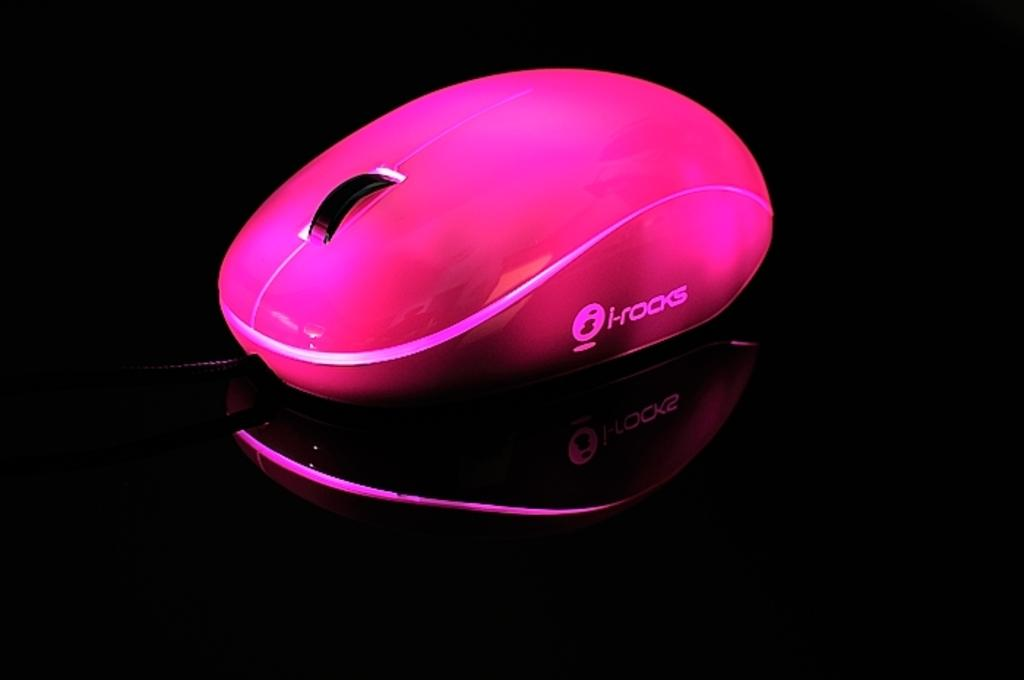What is the color of the mouse in the image? The mouse in the image is pink. What feature does the mouse have for navigating? The mouse has a scroll. Is there any branding or identification on the mouse? Yes, the mouse has a logo on it. What is the color of the platform on which the mouse is placed? The platform is black. What direction is the daughter of the mouse moving in the image? There is no daughter of the mouse present in the image, and the mouse itself is not shown moving in any direction. 